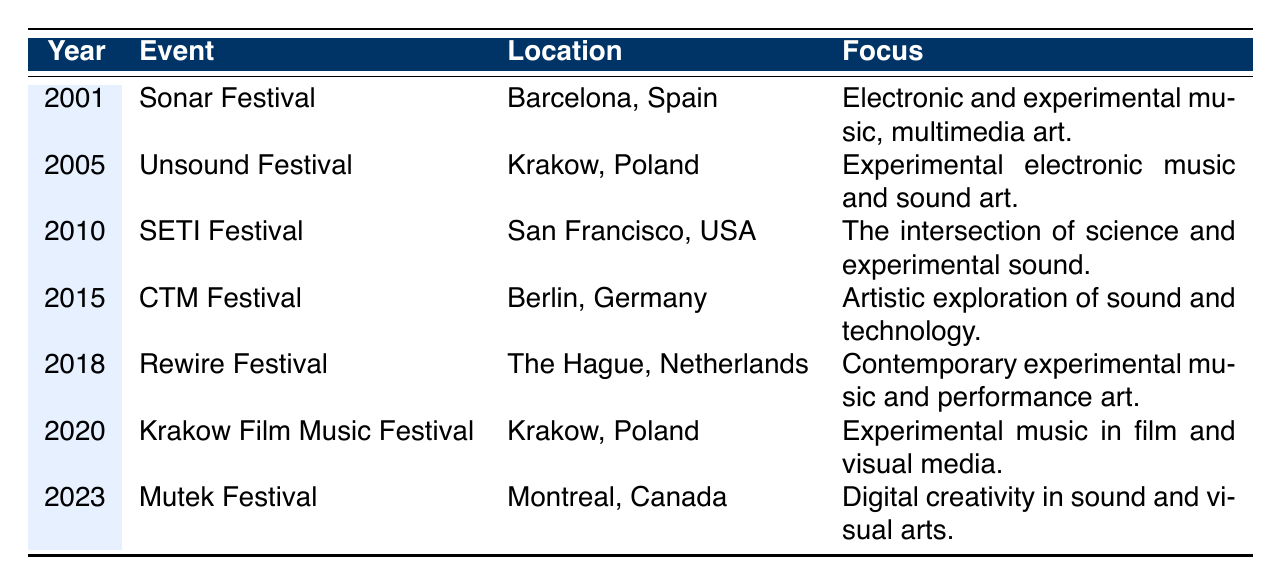What is the location of the Sonar Festival? The data indicates that the Sonar Festival took place in Barcelona, Spain in 2001.
Answer: Barcelona, Spain Who performed at the Unsound Festival in 2005? According to the table, notable performers at the Unsound Festival in 2005 included Kraftwerk and Oneohtrix Point Never.
Answer: Kraftwerk, Oneohtrix Point Never Which event had the focus on "the intersection of science and experimental sound"? The SETI Festival, held in 2010, is noted for this focus in the table.
Answer: SETI Festival How many festivals are listed in the table from 2000 to 2023? There are a total of 11 events listed in the table.
Answer: 11 What is the common theme found in the focus of the CTM Festival in 2015? The focus of the CTM Festival is described as the artistic exploration of sound and technology, which aligns with the evolving nature of experimental music.
Answer: Artistic exploration of sound and technology True or false: The Rewire Festival was held in a country other than the Netherlands. The table states that the Rewire Festival was held in The Hague, Netherlands, so the statement is false.
Answer: False Which festival featured the notable performers Tim Hecker and Jlin? The Rewire Festival is mentioned in the table as featuring Tim Hecker and Jlin in 2018.
Answer: Rewire Festival Between which years does the table list events? The events span from 2001 to 2023 according to the data presented in the table.
Answer: 2001 to 2023 List the event with the earliest year and its location. The earliest event in the table is the Sonar Festival held in Barcelona, Spain in 2001.
Answer: Sonar Festival, Barcelona, Spain Which festivals in the data took place in Poland? The table lists the Unsound Festival in 2005 and the Krakow Film Music Festival in 2020 as events that took place in Poland.
Answer: Unsound Festival, Krakow Film Music Festival What is the focus of the Mutek Festival in 2023? The Mutek Festival, according to the table, has a focus on digital creativity in sound and visual arts.
Answer: Digital creativity in sound and visual arts Which event represents the most recent year in the table? The most recent event listed in the table is the Mutek Festival, which took place in 2023.
Answer: Mutek Festival 